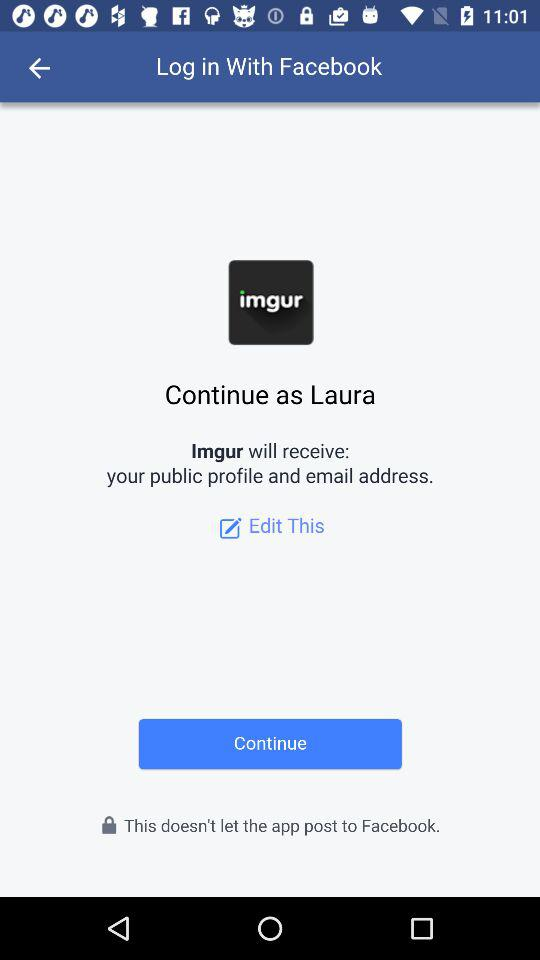What is the name of the user? The name of the user is Laura. 